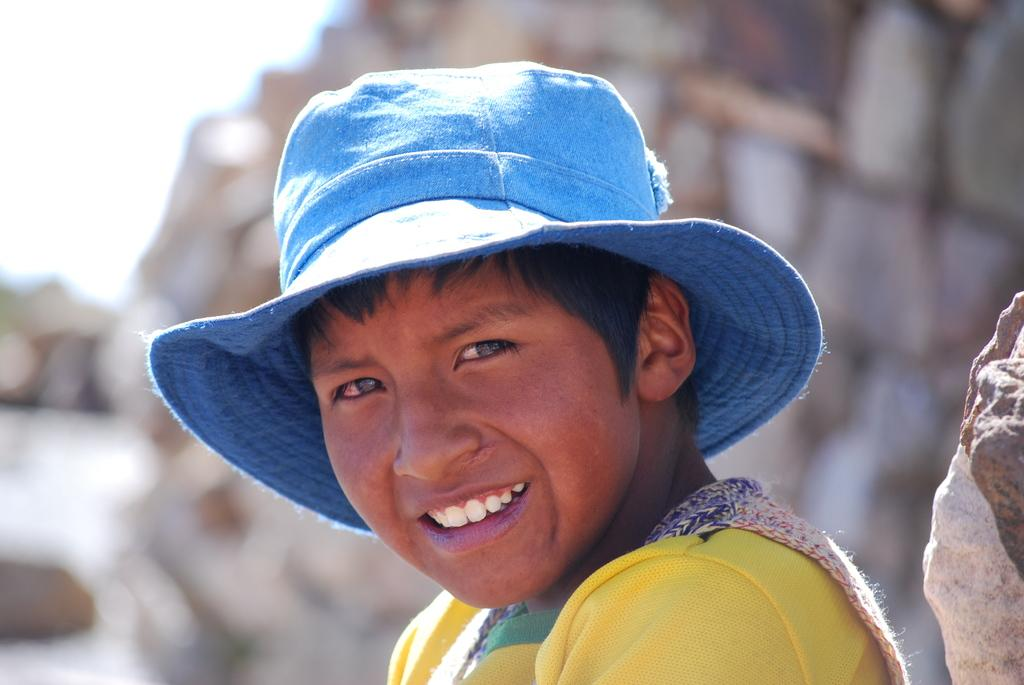What is the main subject in the foreground of the image? There is a boy in the foreground of the image. What is the boy wearing on his head? The boy is wearing a hat. What is the boy's facial expression in the image? The boy is smiling. What can be seen on the right side of the image? There is a rock on the right side of the image. How would you describe the background of the image? The background of the image is blurry. What type of ray is visible in the image? There is no ray present in the image. Is the boy reading a notebook in the image? There is no notebook visible in the image, and the boy is not shown reading. 